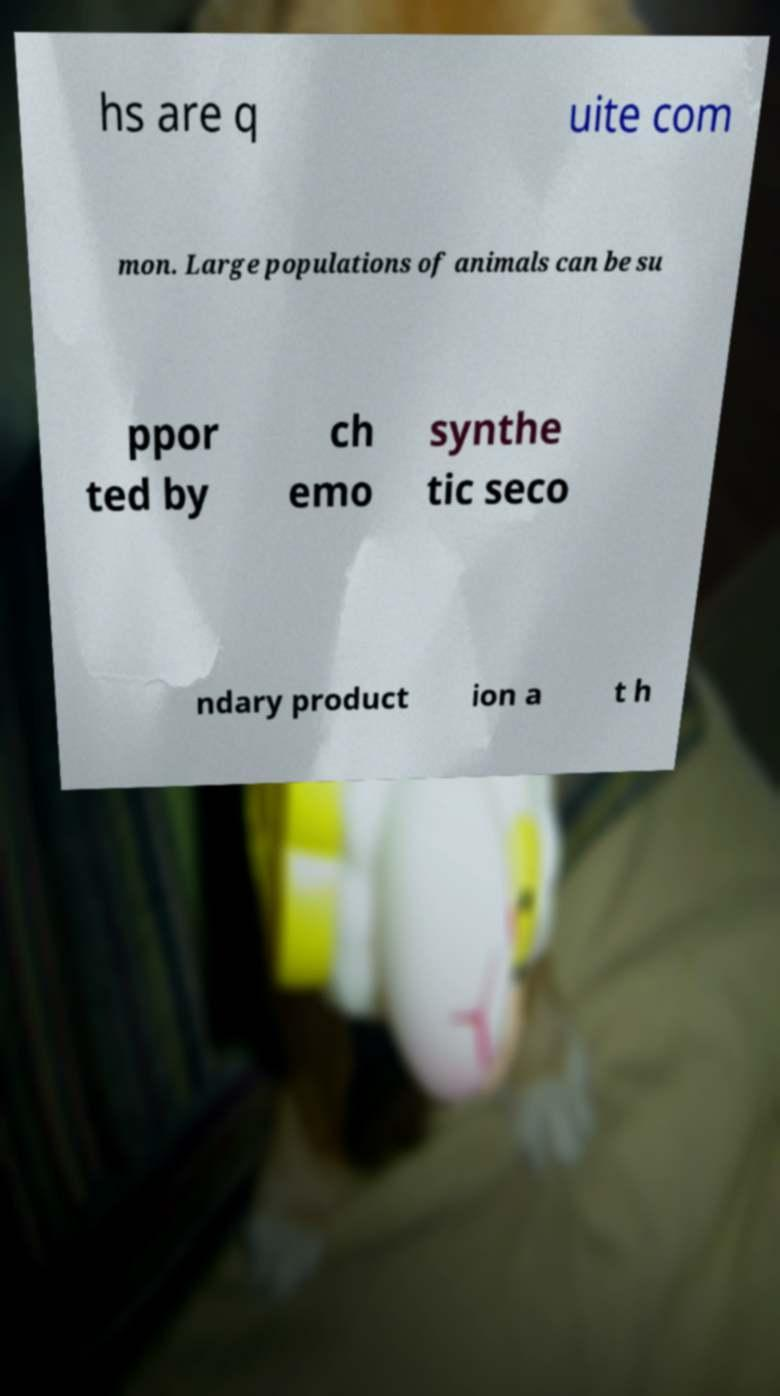Please read and relay the text visible in this image. What does it say? hs are q uite com mon. Large populations of animals can be su ppor ted by ch emo synthe tic seco ndary product ion a t h 